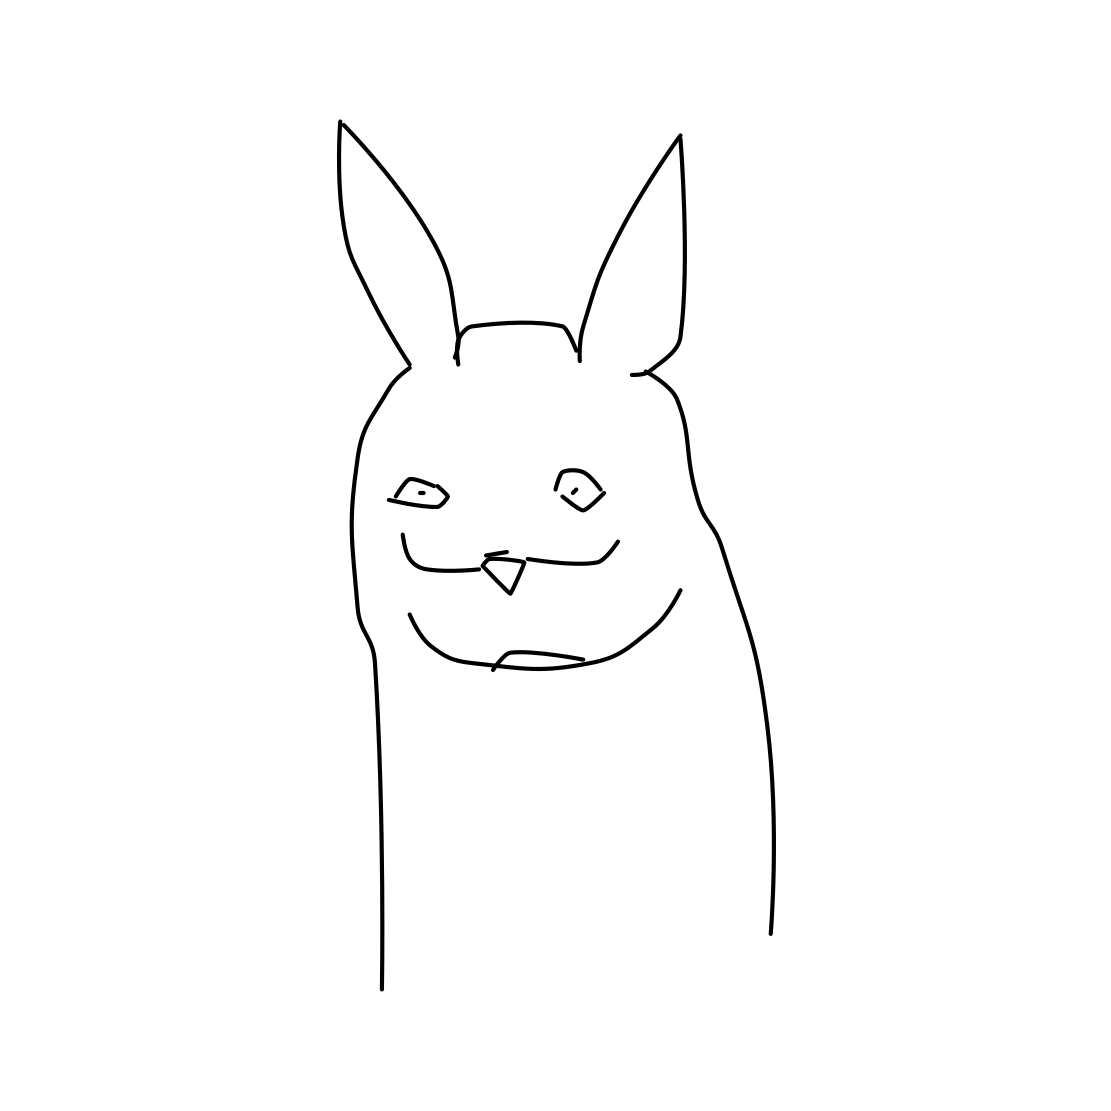Is there a sketchy crown in the picture? No, there isn't a sketchy crown in the picture. The image features a stylized drawing of a character resembling a rabbit with a subtle, humorous expression, but no elements like a crown are present. 